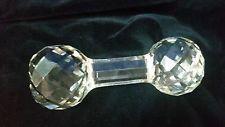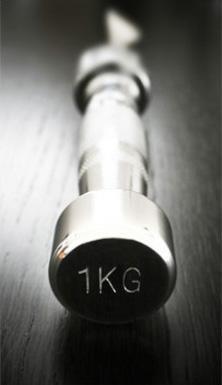The first image is the image on the left, the second image is the image on the right. Considering the images on both sides, is "There is a knife, fork, and spoon in the image on the right." valid? Answer yes or no. No. 